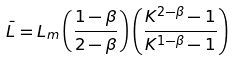Convert formula to latex. <formula><loc_0><loc_0><loc_500><loc_500>\bar { L } = L _ { m } \left ( \frac { 1 - \beta } { 2 - \beta } \right ) \left ( \frac { K ^ { 2 - \beta } - 1 } { K ^ { 1 - \beta } - 1 } \right )</formula> 